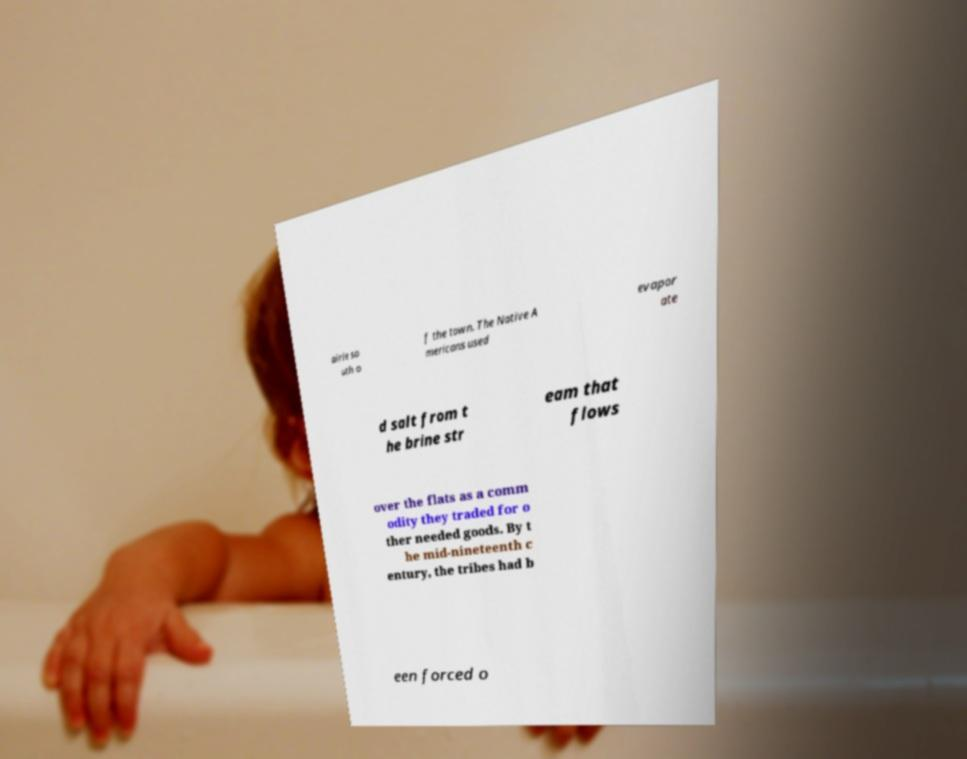Please identify and transcribe the text found in this image. airie so uth o f the town. The Native A mericans used evapor ate d salt from t he brine str eam that flows over the flats as a comm odity they traded for o ther needed goods. By t he mid-nineteenth c entury, the tribes had b een forced o 